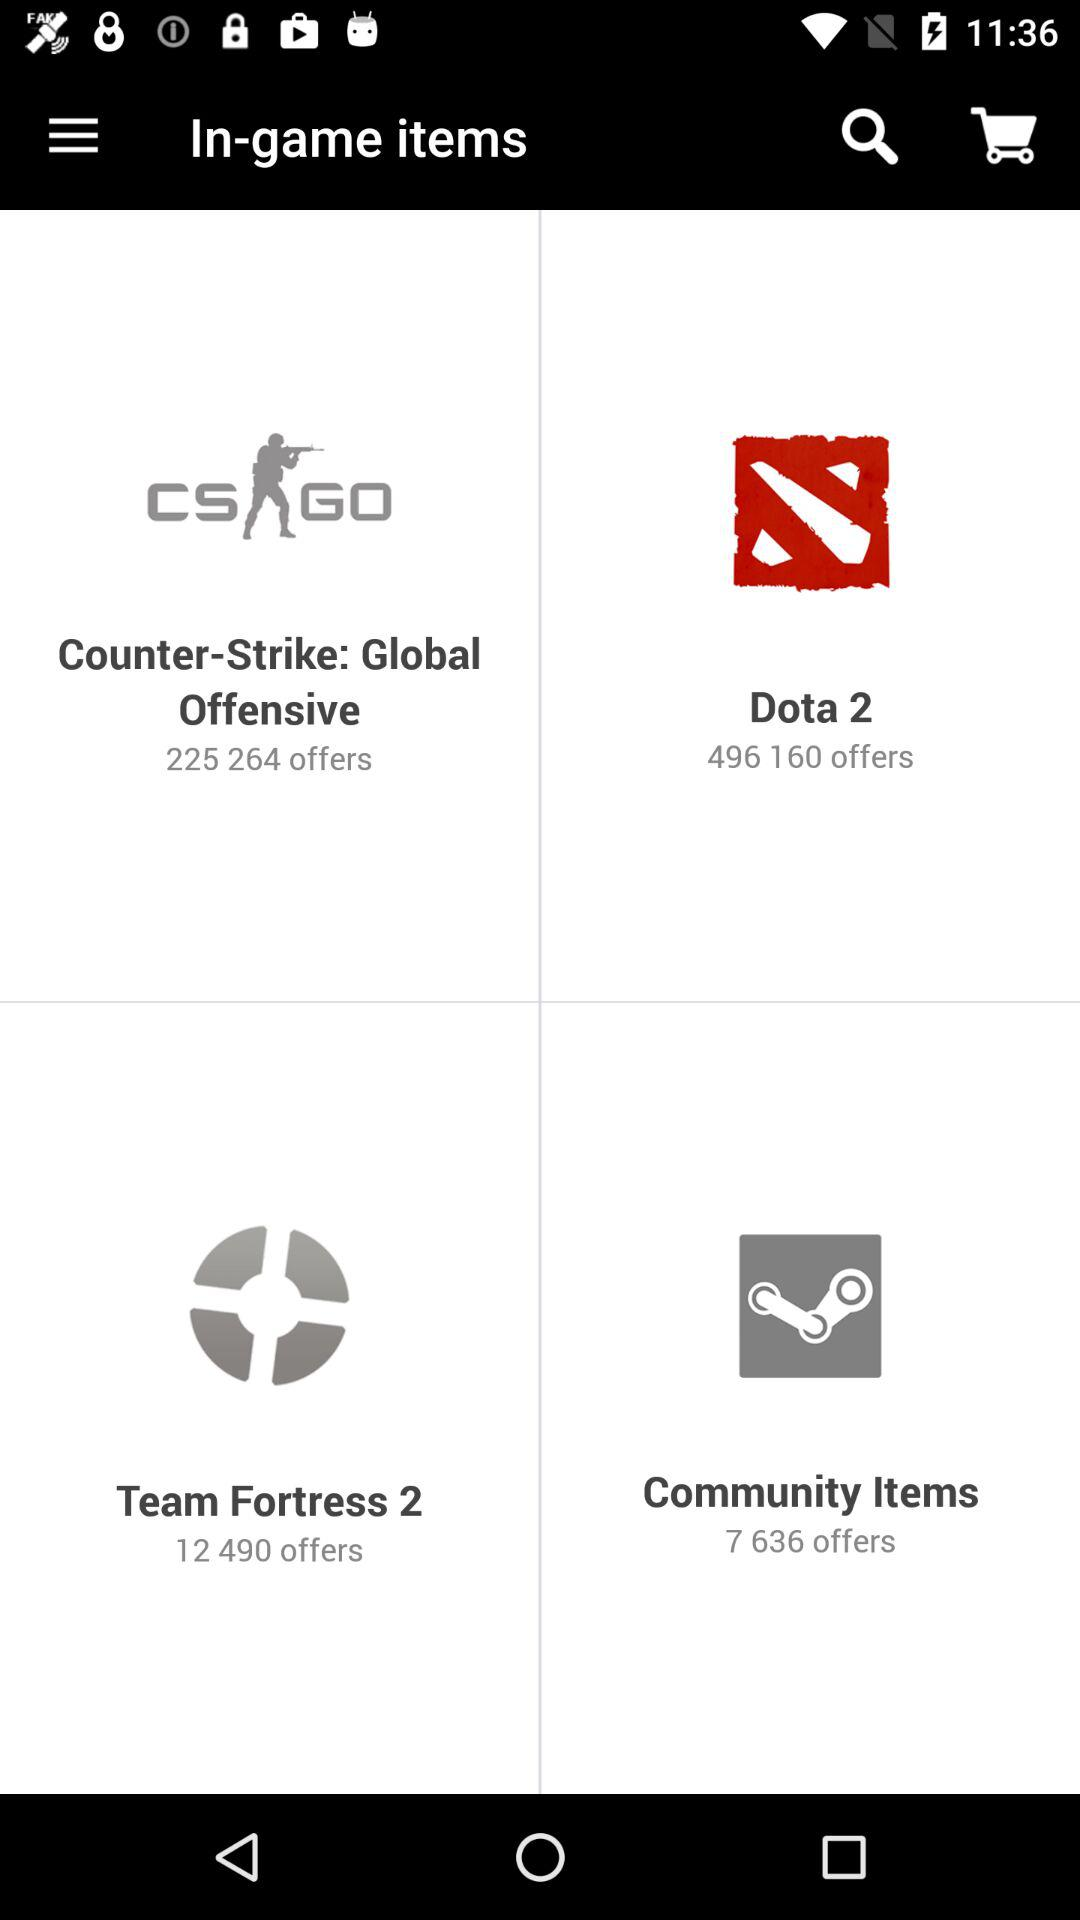Which game has 225,264 offers? The game that has 225,264 offers is "Counter-Strike: Global Offensive". 